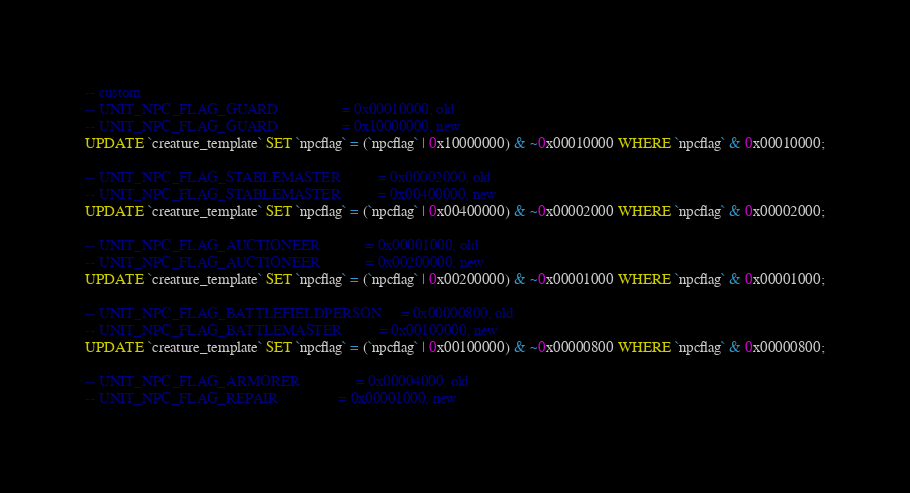Convert code to text. <code><loc_0><loc_0><loc_500><loc_500><_SQL_>-- custom
-- UNIT_NPC_FLAG_GUARD                 = 0x00010000, old
-- UNIT_NPC_FLAG_GUARD                 = 0x10000000, new
UPDATE `creature_template` SET `npcflag` = (`npcflag` | 0x10000000) & ~0x00010000 WHERE `npcflag` & 0x00010000;

-- UNIT_NPC_FLAG_STABLEMASTER          = 0x00002000, old
-- UNIT_NPC_FLAG_STABLEMASTER          = 0x00400000, new
UPDATE `creature_template` SET `npcflag` = (`npcflag` | 0x00400000) & ~0x00002000 WHERE `npcflag` & 0x00002000;

-- UNIT_NPC_FLAG_AUCTIONEER            = 0x00001000, old
-- UNIT_NPC_FLAG_AUCTIONEER            = 0x00200000, new
UPDATE `creature_template` SET `npcflag` = (`npcflag` | 0x00200000) & ~0x00001000 WHERE `npcflag` & 0x00001000;

-- UNIT_NPC_FLAG_BATTLEFIELDPERSON     = 0x00000800, old
-- UNIT_NPC_FLAG_BATTLEMASTER          = 0x00100000, new
UPDATE `creature_template` SET `npcflag` = (`npcflag` | 0x00100000) & ~0x00000800 WHERE `npcflag` & 0x00000800;

-- UNIT_NPC_FLAG_ARMORER               = 0x00004000, old
-- UNIT_NPC_FLAG_REPAIR                = 0x00001000, new</code> 